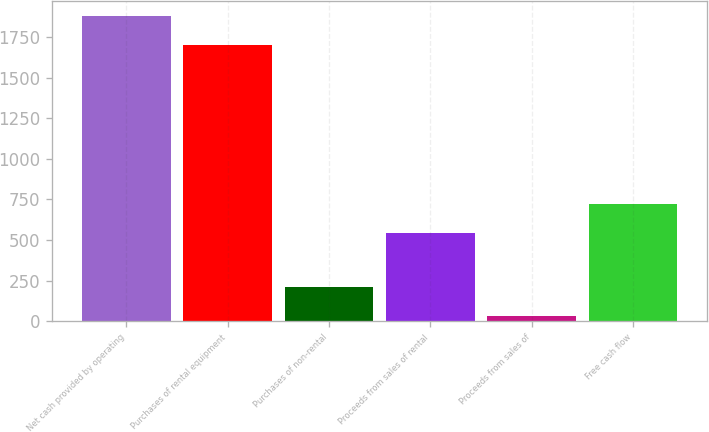<chart> <loc_0><loc_0><loc_500><loc_500><bar_chart><fcel>Net cash provided by operating<fcel>Purchases of rental equipment<fcel>Purchases of non-rental<fcel>Proceeds from sales of rental<fcel>Proceeds from sales of<fcel>Free cash flow<nl><fcel>1877.8<fcel>1701<fcel>209.8<fcel>544<fcel>33<fcel>720.8<nl></chart> 